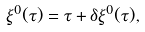Convert formula to latex. <formula><loc_0><loc_0><loc_500><loc_500>\xi ^ { 0 } ( \tau ) = \tau + \delta \xi ^ { 0 } ( \tau ) ,</formula> 